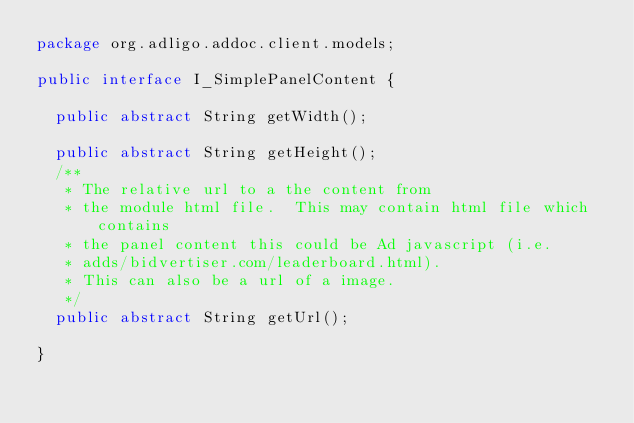Convert code to text. <code><loc_0><loc_0><loc_500><loc_500><_Java_>package org.adligo.addoc.client.models;

public interface I_SimplePanelContent {

  public abstract String getWidth();

  public abstract String getHeight();
  /**
   * The relative url to a the content from
   * the module html file.  This may contain html file which contains
   * the panel content this could be Ad javascript (i.e.
   * adds/bidvertiser.com/leaderboard.html).  
   * This can also be a url of a image.
   */
  public abstract String getUrl();

}</code> 